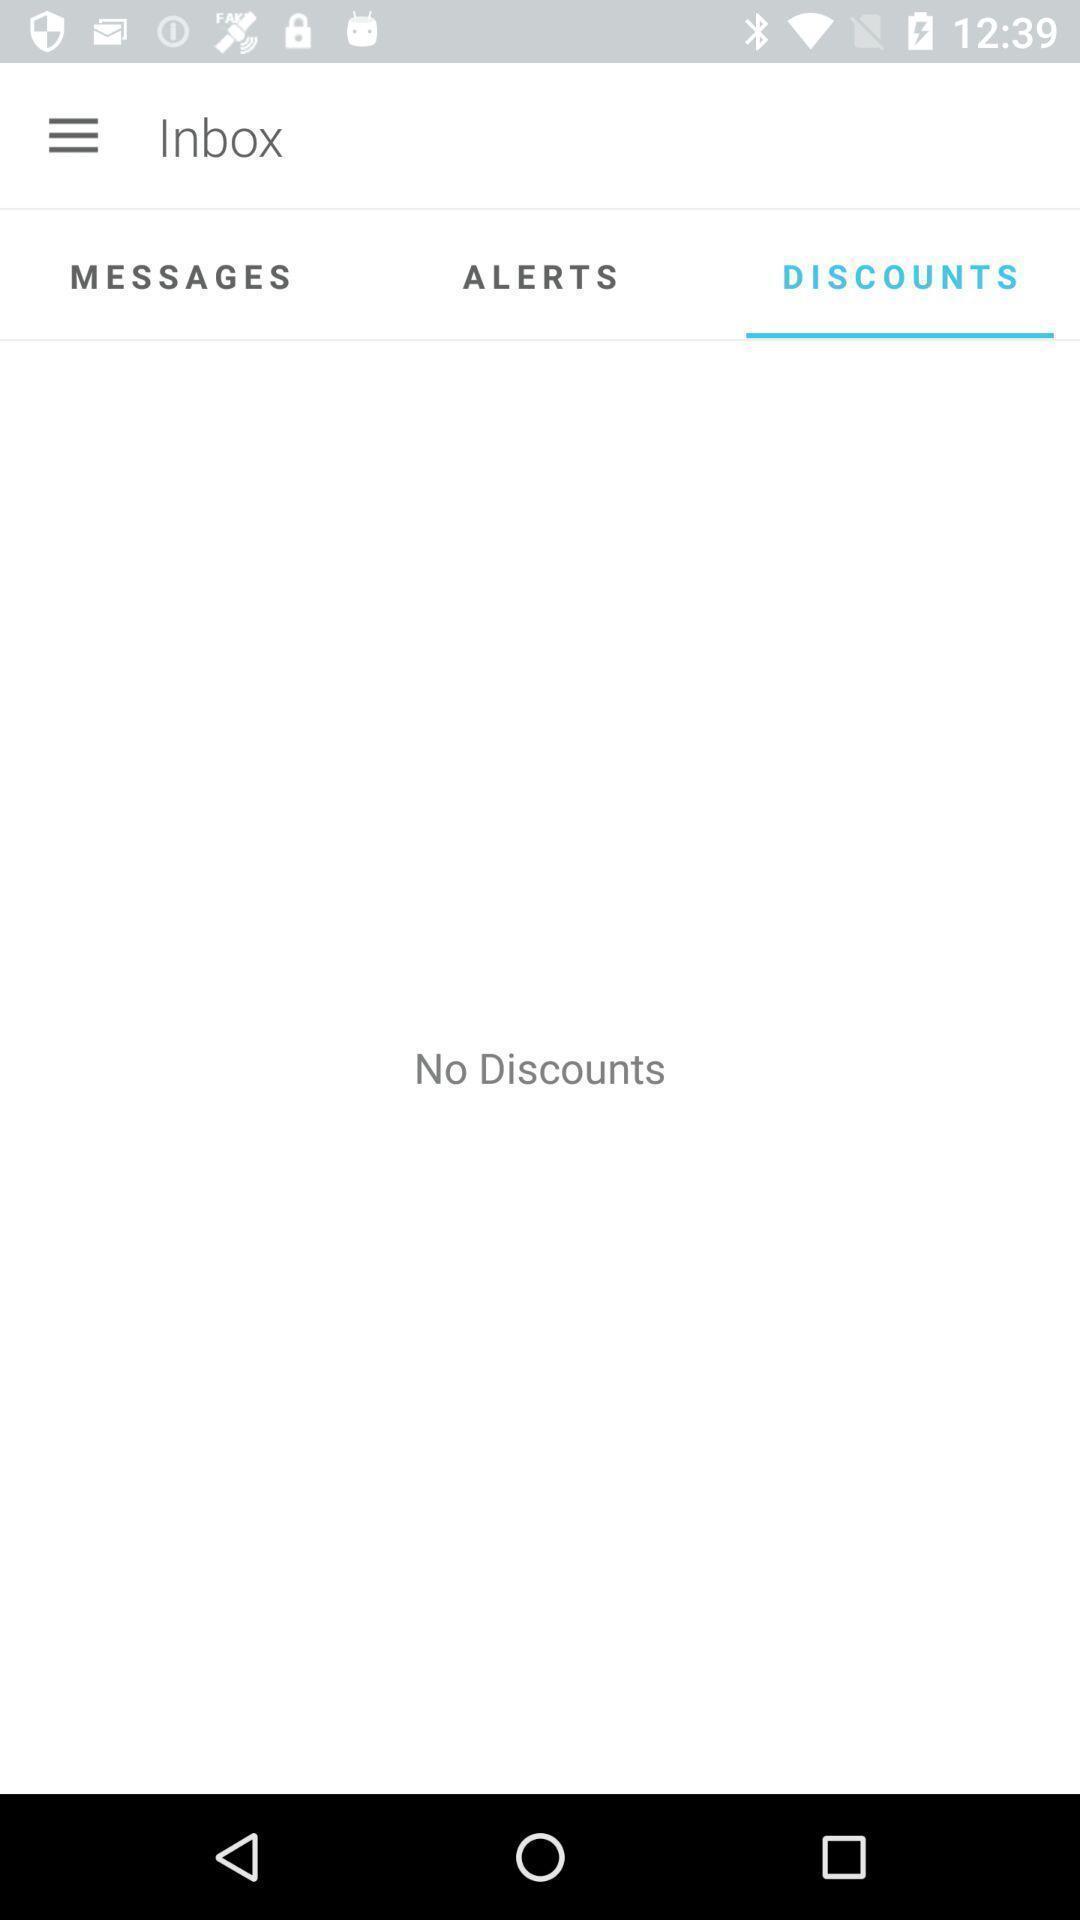Provide a textual representation of this image. Screen displaying the blank page in discounts tab. 